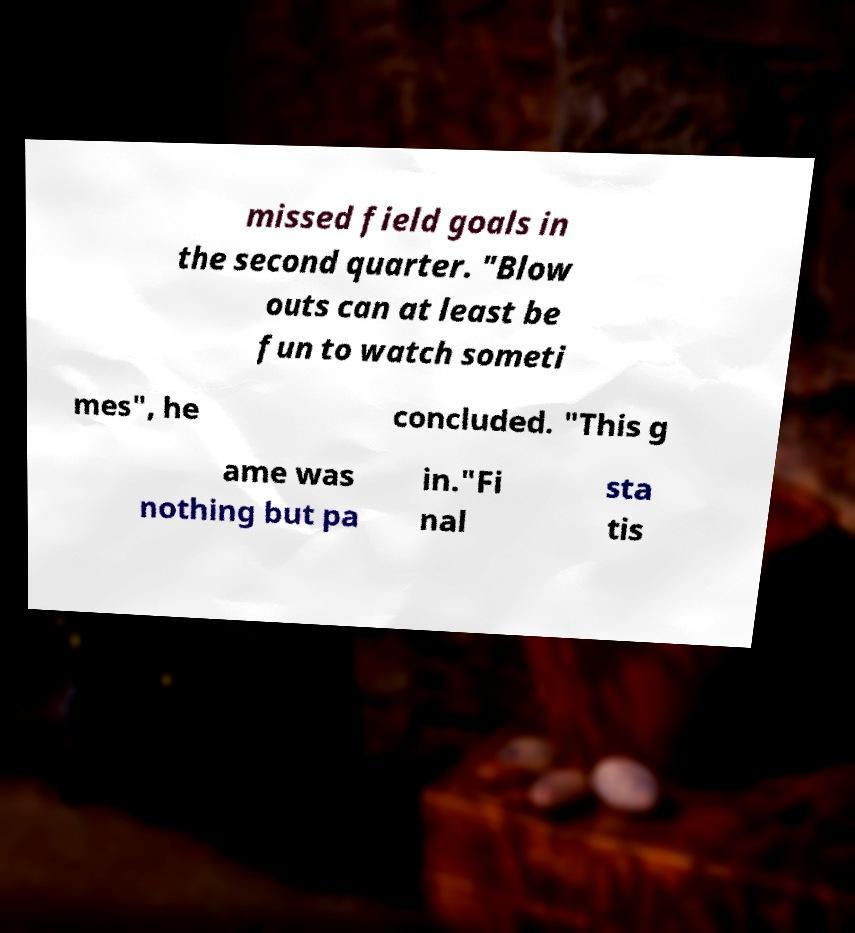There's text embedded in this image that I need extracted. Can you transcribe it verbatim? missed field goals in the second quarter. "Blow outs can at least be fun to watch someti mes", he concluded. "This g ame was nothing but pa in."Fi nal sta tis 